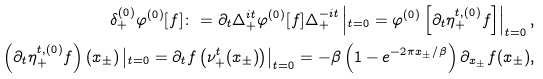Convert formula to latex. <formula><loc_0><loc_0><loc_500><loc_500>\delta _ { + } ^ { ( 0 ) } \varphi ^ { ( 0 ) } [ f ] \colon = \partial _ { t } \Delta _ { + } ^ { i t } \varphi ^ { ( 0 ) } [ f ] \Delta _ { + } ^ { - i t } \left | _ { t = 0 } = \varphi ^ { ( 0 ) } \left [ \partial _ { t } \eta _ { + } ^ { t , ( 0 ) } f \right ] \right | _ { t = 0 } , \\ \left ( \partial _ { t } \eta _ { + } ^ { t , ( 0 ) } f \right ) ( x _ { \pm } ) \left | _ { t = 0 } = \partial _ { t } f \left ( \nu _ { + } ^ { t } ( x _ { \pm } ) \right ) \right | _ { t = 0 } = - \beta \left ( 1 - e ^ { - 2 \pi x _ { \pm } / \beta } \right ) \partial _ { x _ { \pm } } f ( x _ { \pm } ) ,</formula> 